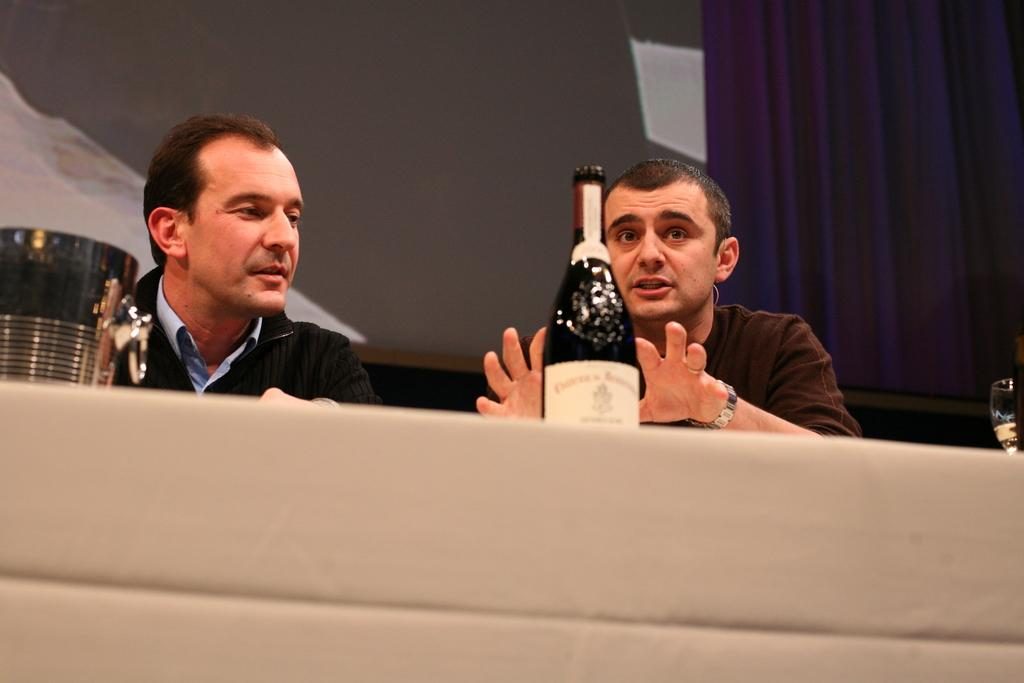How many people are in the image? There are two men in the image. What objects are in front of the men? There is a bottle and a bucket in front of the men. What color is the jacket worn by the person on the left side? The person on the left side is wearing a black color jacket. What can be seen in the background of the image? There are curtains in the background of the image. What type of breakfast is being prepared by the men in the image? There is no indication of breakfast or any food preparation in the image; it only shows two men with a bottle and a bucket in front of them. Can you see a hook in the image? There is no hook visible in the image. 